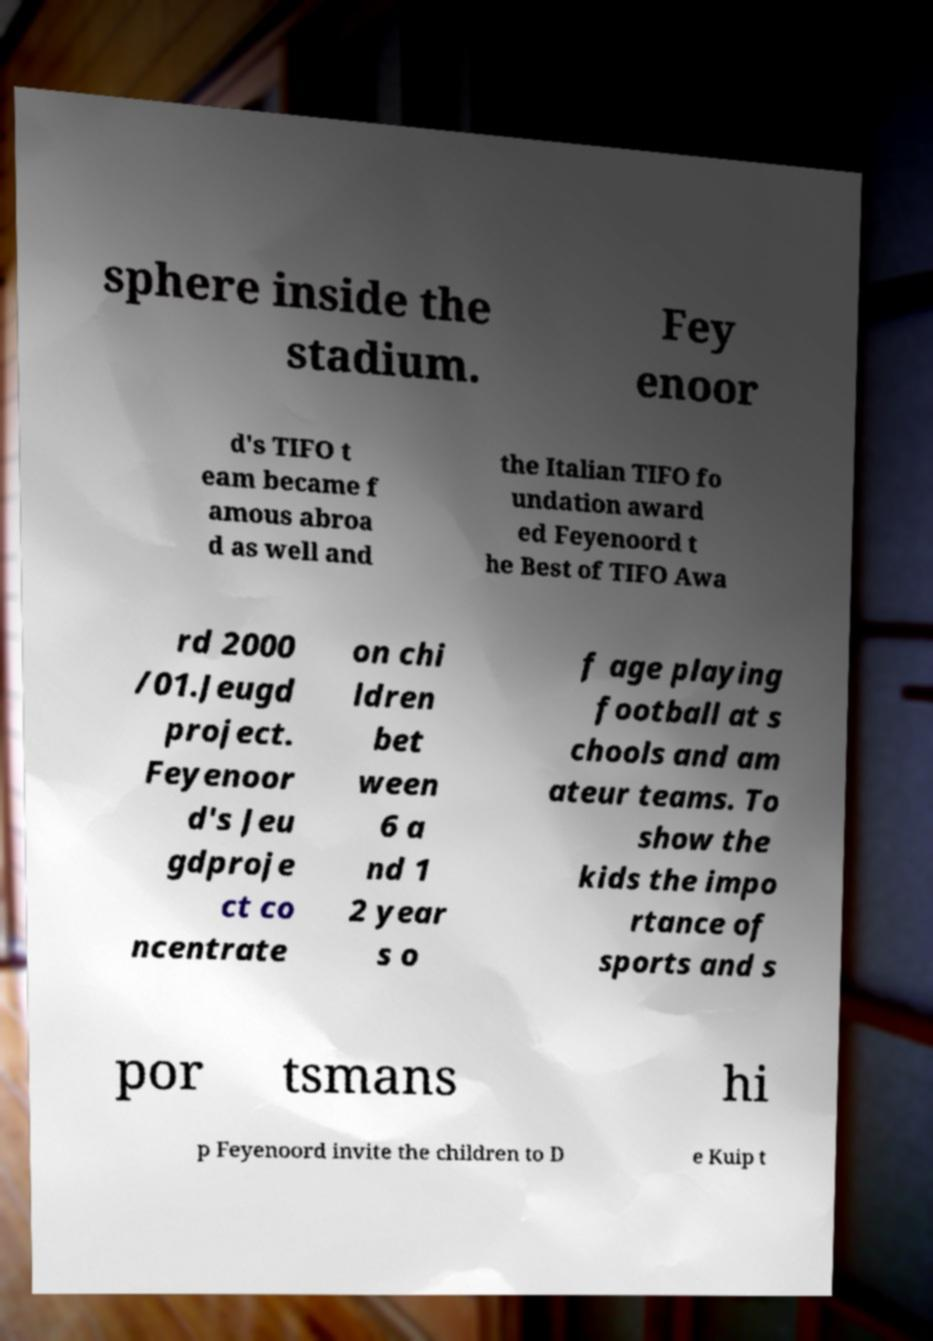Could you assist in decoding the text presented in this image and type it out clearly? sphere inside the stadium. Fey enoor d's TIFO t eam became f amous abroa d as well and the Italian TIFO fo undation award ed Feyenoord t he Best of TIFO Awa rd 2000 /01.Jeugd project. Feyenoor d's Jeu gdproje ct co ncentrate on chi ldren bet ween 6 a nd 1 2 year s o f age playing football at s chools and am ateur teams. To show the kids the impo rtance of sports and s por tsmans hi p Feyenoord invite the children to D e Kuip t 